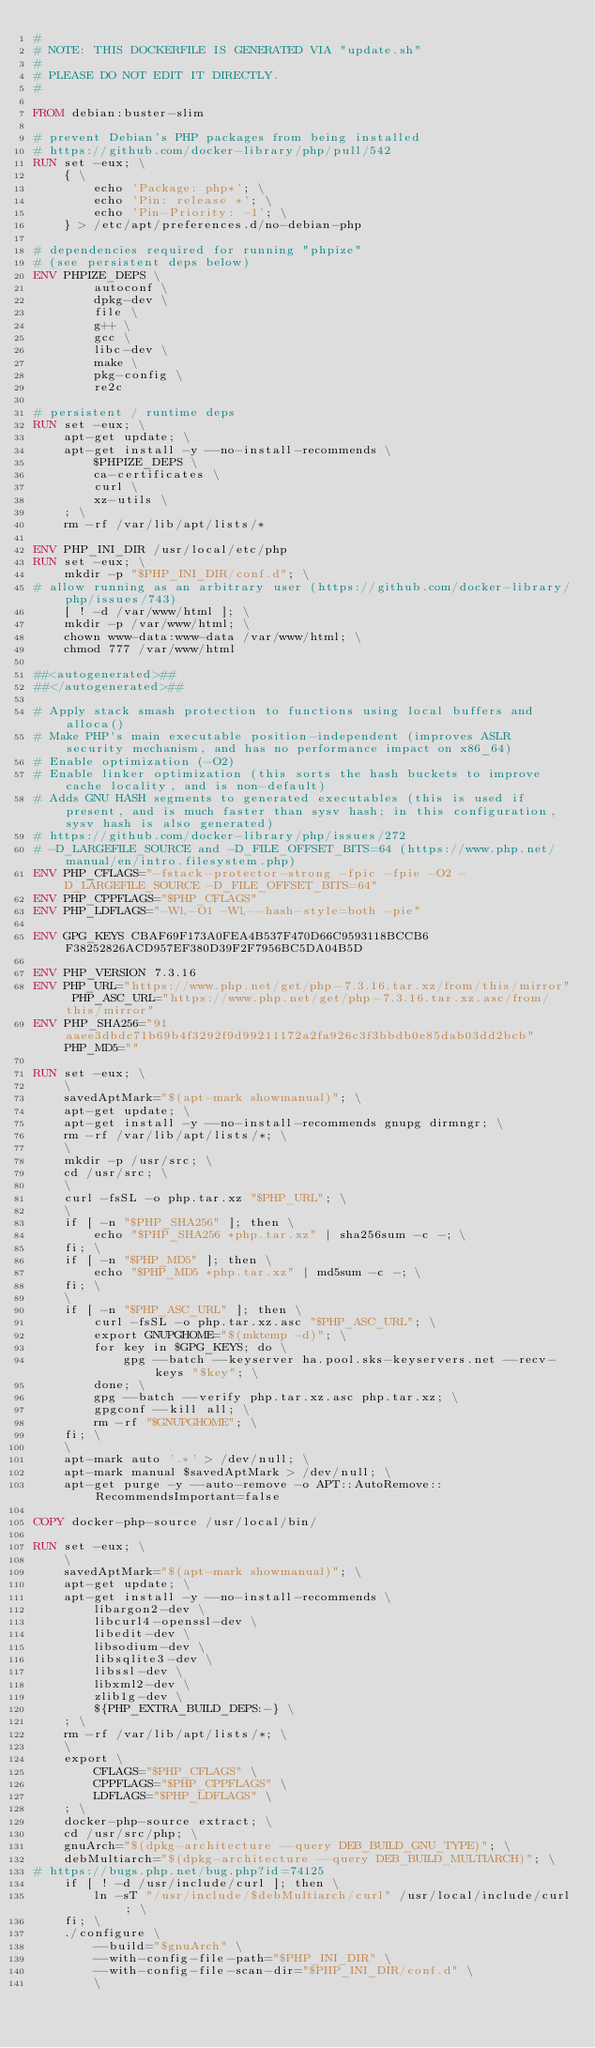Convert code to text. <code><loc_0><loc_0><loc_500><loc_500><_Dockerfile_>#
# NOTE: THIS DOCKERFILE IS GENERATED VIA "update.sh"
#
# PLEASE DO NOT EDIT IT DIRECTLY.
#

FROM debian:buster-slim

# prevent Debian's PHP packages from being installed
# https://github.com/docker-library/php/pull/542
RUN set -eux; \
	{ \
		echo 'Package: php*'; \
		echo 'Pin: release *'; \
		echo 'Pin-Priority: -1'; \
	} > /etc/apt/preferences.d/no-debian-php

# dependencies required for running "phpize"
# (see persistent deps below)
ENV PHPIZE_DEPS \
		autoconf \
		dpkg-dev \
		file \
		g++ \
		gcc \
		libc-dev \
		make \
		pkg-config \
		re2c

# persistent / runtime deps
RUN set -eux; \
	apt-get update; \
	apt-get install -y --no-install-recommends \
		$PHPIZE_DEPS \
		ca-certificates \
		curl \
		xz-utils \
	; \
	rm -rf /var/lib/apt/lists/*

ENV PHP_INI_DIR /usr/local/etc/php
RUN set -eux; \
	mkdir -p "$PHP_INI_DIR/conf.d"; \
# allow running as an arbitrary user (https://github.com/docker-library/php/issues/743)
	[ ! -d /var/www/html ]; \
	mkdir -p /var/www/html; \
	chown www-data:www-data /var/www/html; \
	chmod 777 /var/www/html

##<autogenerated>##
##</autogenerated>##

# Apply stack smash protection to functions using local buffers and alloca()
# Make PHP's main executable position-independent (improves ASLR security mechanism, and has no performance impact on x86_64)
# Enable optimization (-O2)
# Enable linker optimization (this sorts the hash buckets to improve cache locality, and is non-default)
# Adds GNU HASH segments to generated executables (this is used if present, and is much faster than sysv hash; in this configuration, sysv hash is also generated)
# https://github.com/docker-library/php/issues/272
# -D_LARGEFILE_SOURCE and -D_FILE_OFFSET_BITS=64 (https://www.php.net/manual/en/intro.filesystem.php)
ENV PHP_CFLAGS="-fstack-protector-strong -fpic -fpie -O2 -D_LARGEFILE_SOURCE -D_FILE_OFFSET_BITS=64"
ENV PHP_CPPFLAGS="$PHP_CFLAGS"
ENV PHP_LDFLAGS="-Wl,-O1 -Wl,--hash-style=both -pie"

ENV GPG_KEYS CBAF69F173A0FEA4B537F470D66C9593118BCCB6 F38252826ACD957EF380D39F2F7956BC5DA04B5D

ENV PHP_VERSION 7.3.16
ENV PHP_URL="https://www.php.net/get/php-7.3.16.tar.xz/from/this/mirror" PHP_ASC_URL="https://www.php.net/get/php-7.3.16.tar.xz.asc/from/this/mirror"
ENV PHP_SHA256="91aaee3dbdc71b69b4f3292f9d99211172a2fa926c3f3bbdb0e85dab03dd2bcb" PHP_MD5=""

RUN set -eux; \
	\
	savedAptMark="$(apt-mark showmanual)"; \
	apt-get update; \
	apt-get install -y --no-install-recommends gnupg dirmngr; \
	rm -rf /var/lib/apt/lists/*; \
	\
	mkdir -p /usr/src; \
	cd /usr/src; \
	\
	curl -fsSL -o php.tar.xz "$PHP_URL"; \
	\
	if [ -n "$PHP_SHA256" ]; then \
		echo "$PHP_SHA256 *php.tar.xz" | sha256sum -c -; \
	fi; \
	if [ -n "$PHP_MD5" ]; then \
		echo "$PHP_MD5 *php.tar.xz" | md5sum -c -; \
	fi; \
	\
	if [ -n "$PHP_ASC_URL" ]; then \
		curl -fsSL -o php.tar.xz.asc "$PHP_ASC_URL"; \
		export GNUPGHOME="$(mktemp -d)"; \
		for key in $GPG_KEYS; do \
			gpg --batch --keyserver ha.pool.sks-keyservers.net --recv-keys "$key"; \
		done; \
		gpg --batch --verify php.tar.xz.asc php.tar.xz; \
		gpgconf --kill all; \
		rm -rf "$GNUPGHOME"; \
	fi; \
	\
	apt-mark auto '.*' > /dev/null; \
	apt-mark manual $savedAptMark > /dev/null; \
	apt-get purge -y --auto-remove -o APT::AutoRemove::RecommendsImportant=false

COPY docker-php-source /usr/local/bin/

RUN set -eux; \
	\
	savedAptMark="$(apt-mark showmanual)"; \
	apt-get update; \
	apt-get install -y --no-install-recommends \
		libargon2-dev \
		libcurl4-openssl-dev \
		libedit-dev \
		libsodium-dev \
		libsqlite3-dev \
		libssl-dev \
		libxml2-dev \
		zlib1g-dev \
		${PHP_EXTRA_BUILD_DEPS:-} \
	; \
	rm -rf /var/lib/apt/lists/*; \
	\
	export \
		CFLAGS="$PHP_CFLAGS" \
		CPPFLAGS="$PHP_CPPFLAGS" \
		LDFLAGS="$PHP_LDFLAGS" \
	; \
	docker-php-source extract; \
	cd /usr/src/php; \
	gnuArch="$(dpkg-architecture --query DEB_BUILD_GNU_TYPE)"; \
	debMultiarch="$(dpkg-architecture --query DEB_BUILD_MULTIARCH)"; \
# https://bugs.php.net/bug.php?id=74125
	if [ ! -d /usr/include/curl ]; then \
		ln -sT "/usr/include/$debMultiarch/curl" /usr/local/include/curl; \
	fi; \
	./configure \
		--build="$gnuArch" \
		--with-config-file-path="$PHP_INI_DIR" \
		--with-config-file-scan-dir="$PHP_INI_DIR/conf.d" \
		\</code> 